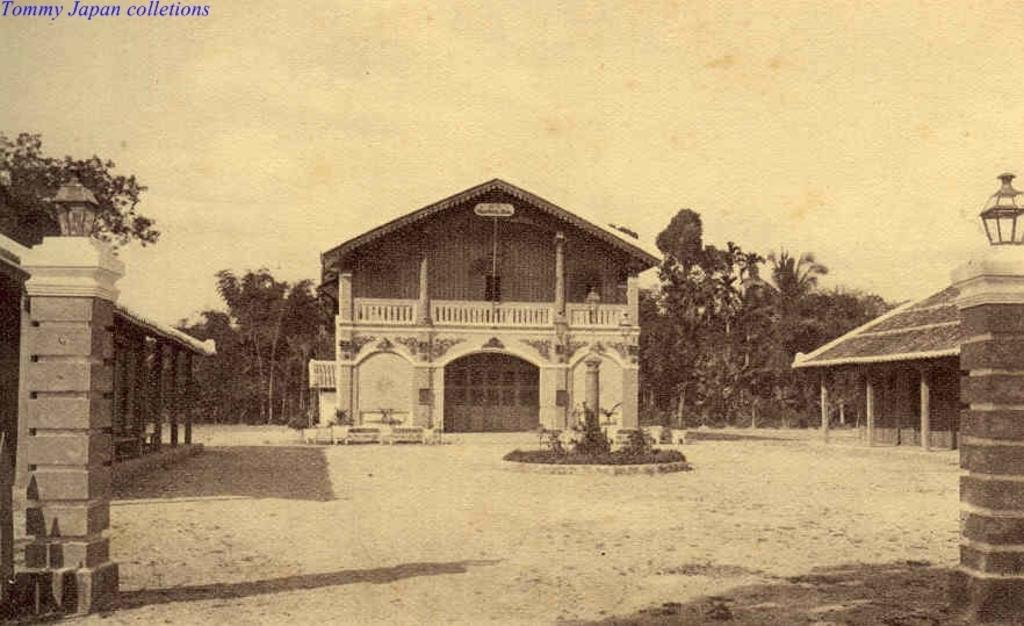What can be seen at the base of the image? The ground is visible in the image. What architectural features are present in the image? There are pillars in the image. What type of lighting is present in the image? Lamps are present in the image. What type of structures can be seen in the image? There are buildings in the image. What type of vegetation is visible in the image? Plants and trees are visible in the image. What other objects can be seen in the image? There are some objects in the image. What is visible in the background of the image? The sky is visible in the background of the image. What is the name of the daughter who is playing on the sidewalk in the image? There is no daughter or sidewalk present in the image. What type of channel can be seen running through the image? There is no channel present in the image. 